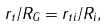<formula> <loc_0><loc_0><loc_500><loc_500>r _ { t } / R _ { G } = r _ { t i } / R _ { i } ,</formula> 